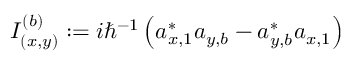Convert formula to latex. <formula><loc_0><loc_0><loc_500><loc_500>I _ { ( x , y ) } ^ { ( b ) } \colon = i \hbar { ^ } { - 1 } \left ( a _ { x , 1 } ^ { \ast } a _ { y , b } - a _ { y , b } ^ { \ast } a _ { x , 1 } \right )</formula> 